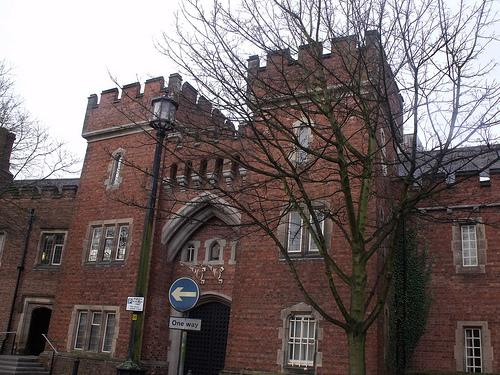Question: what shape is the blue sign?
Choices:
A. Square.
B. Triangle.
C. Circle.
D. Rectangle.
Answer with the letter. Answer: C 